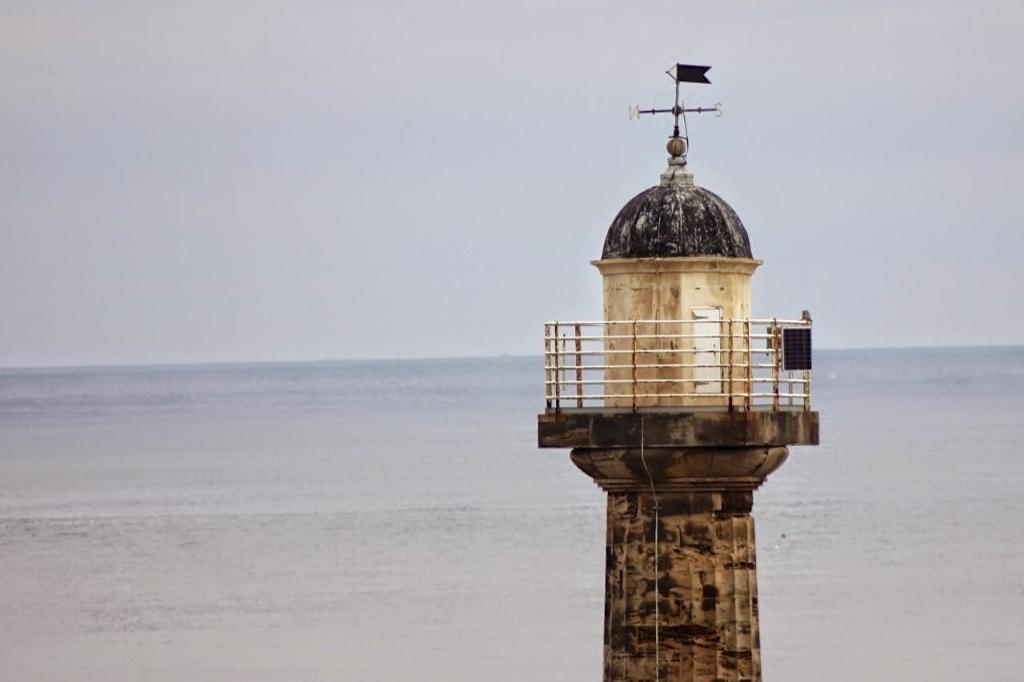What structure is located on the right side of the image? There is a tower on the right side of the image. What can be seen at the bottom side of the image? There is water at the bottom side of the image. How many crows are perched on the tower in the image? There are no crows present in the image; it only features a tower and water. Who is the servant attending to in the image? There is no servant present in the image. 